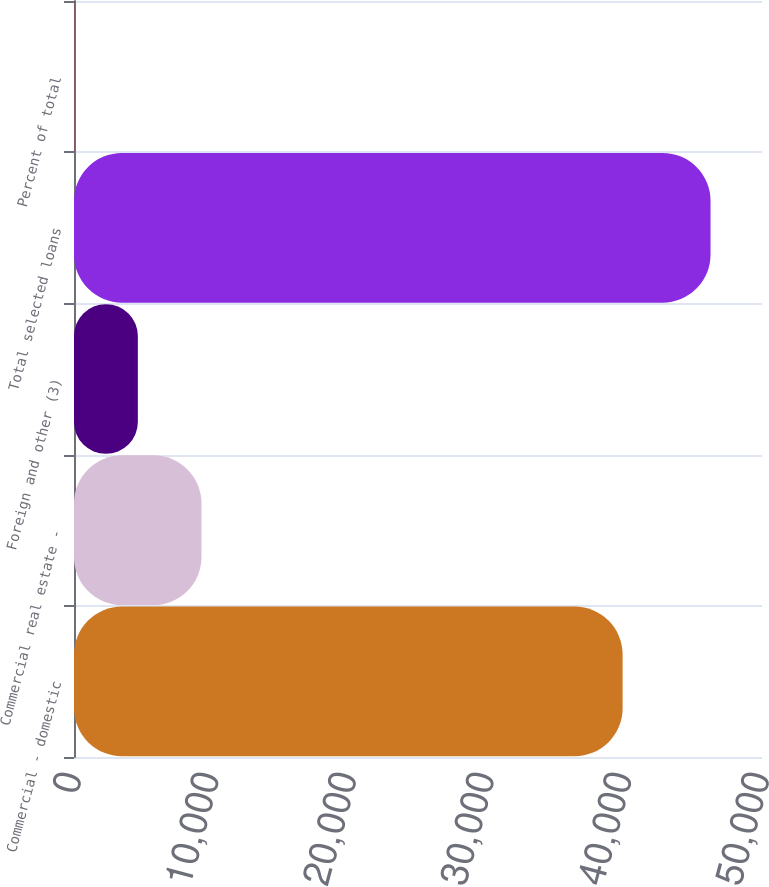Convert chart to OTSL. <chart><loc_0><loc_0><loc_500><loc_500><bar_chart><fcel>Commercial - domestic<fcel>Commercial real estate -<fcel>Foreign and other (3)<fcel>Total selected loans<fcel>Percent of total<nl><fcel>39870<fcel>9264.08<fcel>4639.59<fcel>46260<fcel>15.1<nl></chart> 